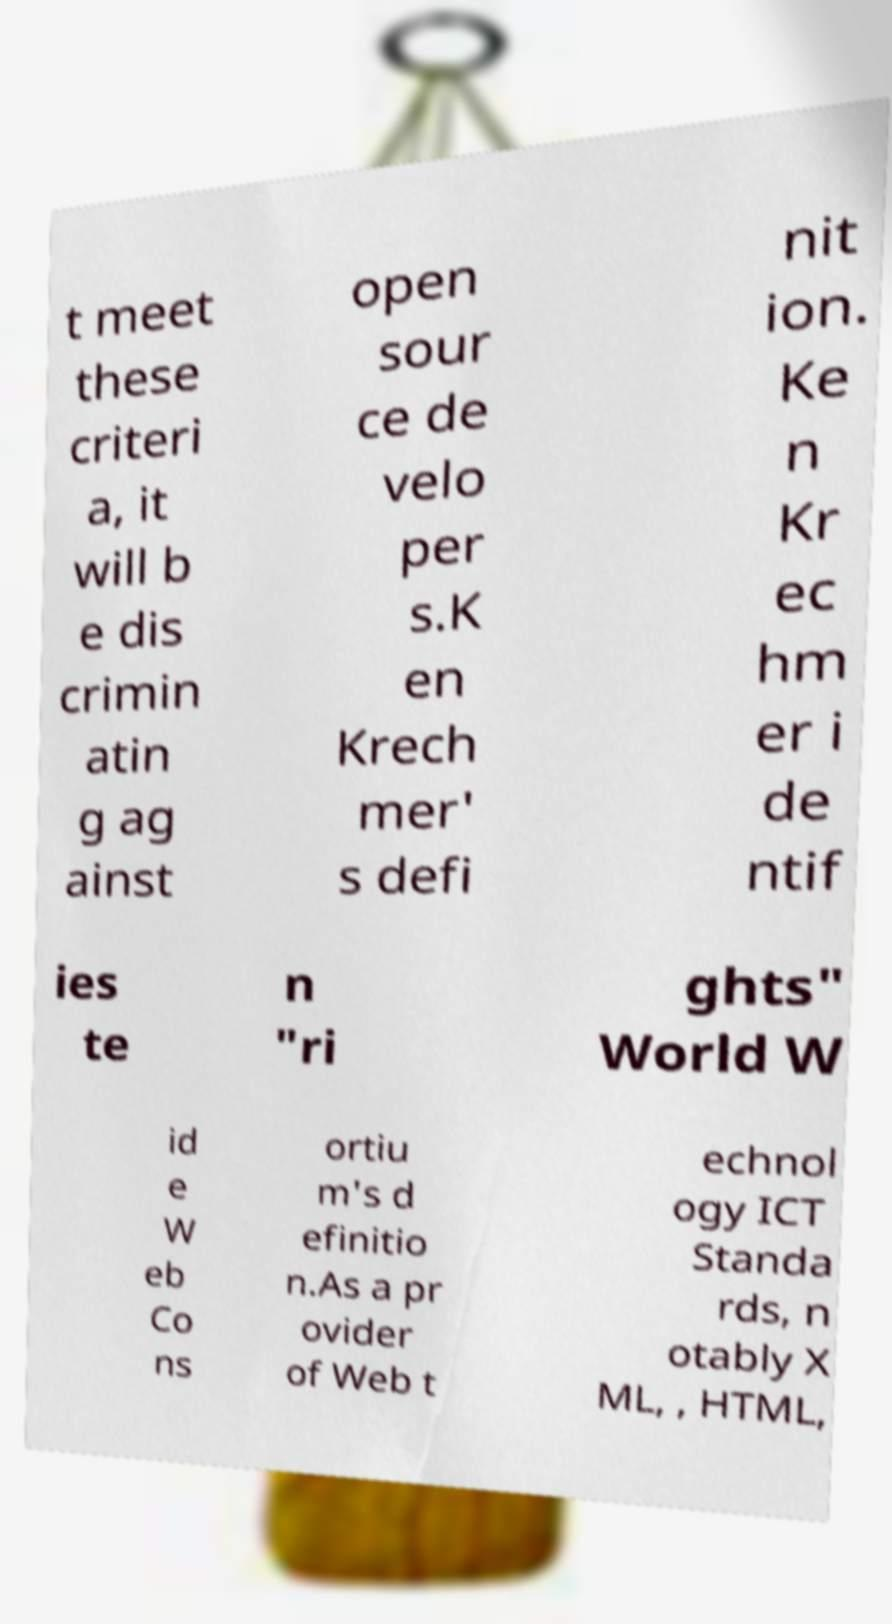I need the written content from this picture converted into text. Can you do that? t meet these criteri a, it will b e dis crimin atin g ag ainst open sour ce de velo per s.K en Krech mer' s defi nit ion. Ke n Kr ec hm er i de ntif ies te n "ri ghts" World W id e W eb Co ns ortiu m's d efinitio n.As a pr ovider of Web t echnol ogy ICT Standa rds, n otably X ML, , HTML, 